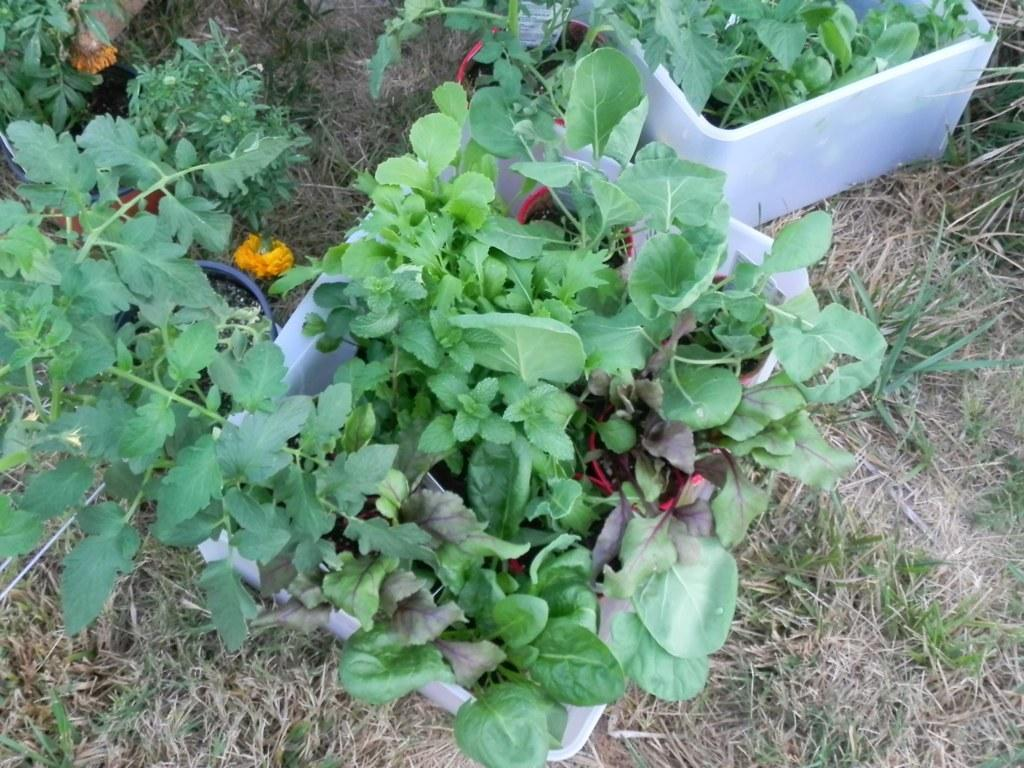What type of living organisms can be seen in the image? Plants can be seen in the image. Where are the plants located? The plants are in flower pots. What invention is being used to cook the soup in the image? There is no soup or invention present in the image; it only features plants in flower pots. 